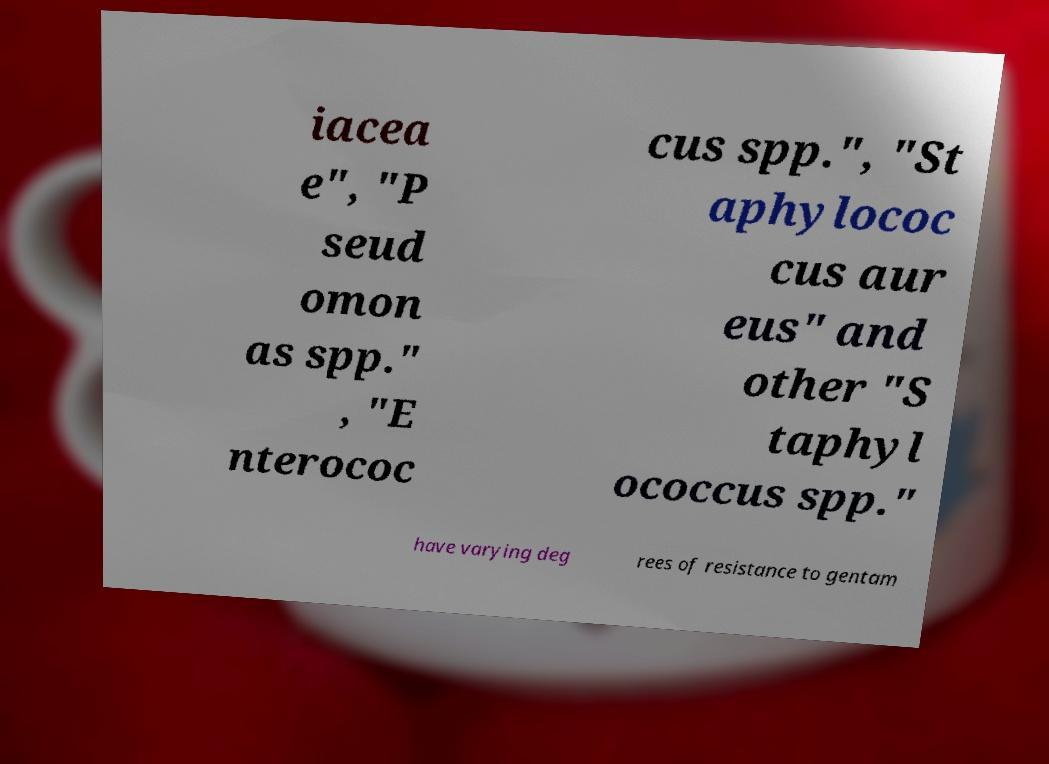There's text embedded in this image that I need extracted. Can you transcribe it verbatim? iacea e", "P seud omon as spp." , "E nterococ cus spp.", "St aphylococ cus aur eus" and other "S taphyl ococcus spp." have varying deg rees of resistance to gentam 